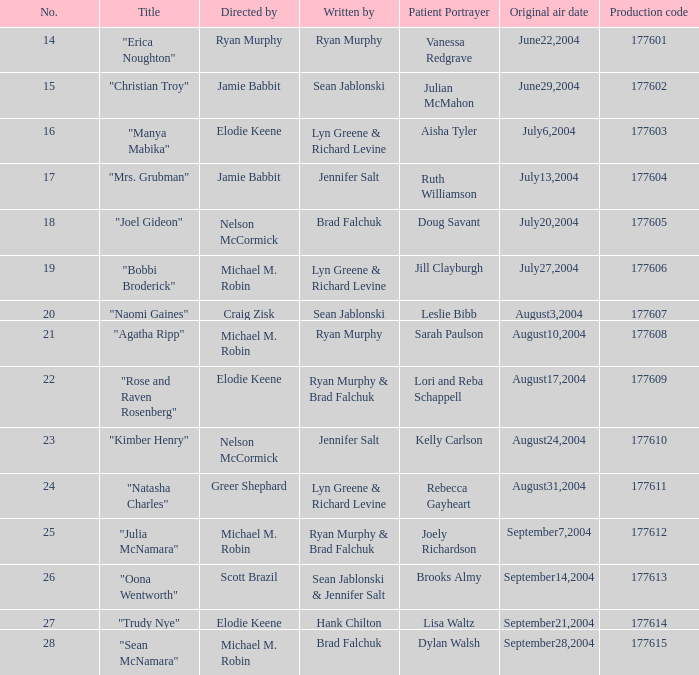Who directed the episode with production code 177605? Nelson McCormick. 